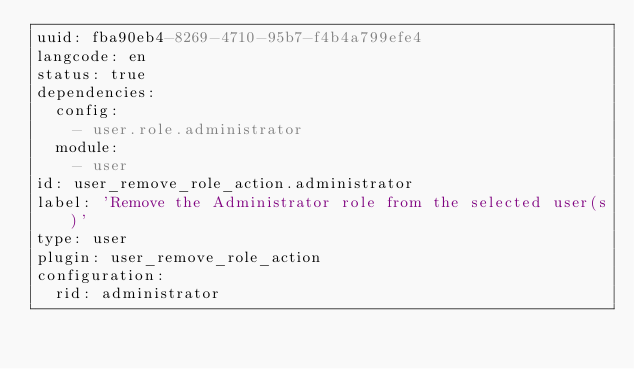Convert code to text. <code><loc_0><loc_0><loc_500><loc_500><_YAML_>uuid: fba90eb4-8269-4710-95b7-f4b4a799efe4
langcode: en
status: true
dependencies:
  config:
    - user.role.administrator
  module:
    - user
id: user_remove_role_action.administrator
label: 'Remove the Administrator role from the selected user(s)'
type: user
plugin: user_remove_role_action
configuration:
  rid: administrator
</code> 